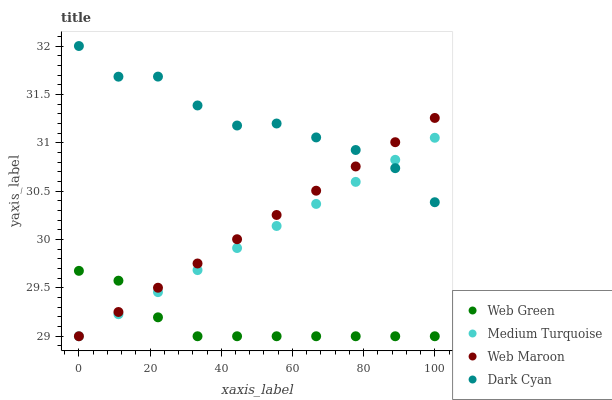Does Web Green have the minimum area under the curve?
Answer yes or no. Yes. Does Dark Cyan have the maximum area under the curve?
Answer yes or no. Yes. Does Web Maroon have the minimum area under the curve?
Answer yes or no. No. Does Web Maroon have the maximum area under the curve?
Answer yes or no. No. Is Web Maroon the smoothest?
Answer yes or no. Yes. Is Dark Cyan the roughest?
Answer yes or no. Yes. Is Medium Turquoise the smoothest?
Answer yes or no. No. Is Medium Turquoise the roughest?
Answer yes or no. No. Does Web Maroon have the lowest value?
Answer yes or no. Yes. Does Dark Cyan have the highest value?
Answer yes or no. Yes. Does Web Maroon have the highest value?
Answer yes or no. No. Is Web Green less than Dark Cyan?
Answer yes or no. Yes. Is Dark Cyan greater than Web Green?
Answer yes or no. Yes. Does Dark Cyan intersect Medium Turquoise?
Answer yes or no. Yes. Is Dark Cyan less than Medium Turquoise?
Answer yes or no. No. Is Dark Cyan greater than Medium Turquoise?
Answer yes or no. No. Does Web Green intersect Dark Cyan?
Answer yes or no. No. 